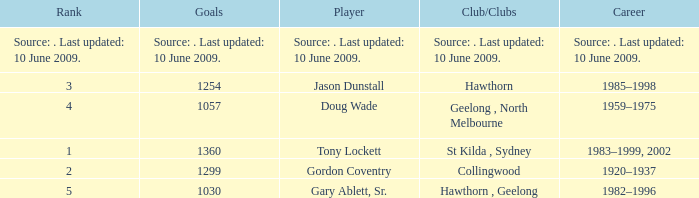In what club(s) does Tony Lockett play? St Kilda , Sydney. 